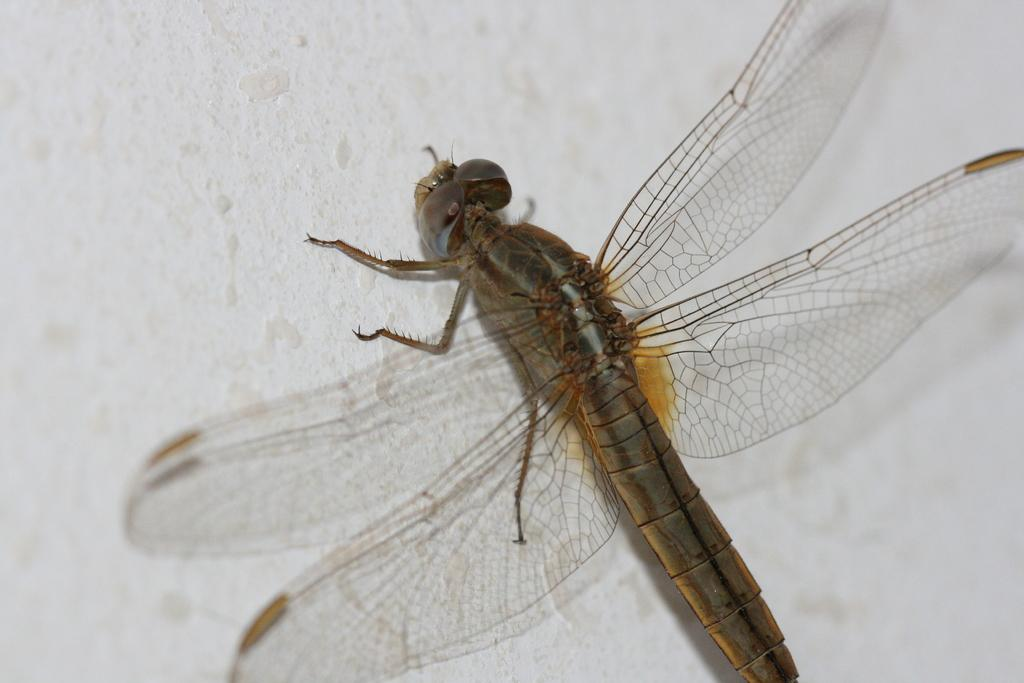What insect is present in the image? There is a dragonfly in the image. What is the color of the surface where the dragonfly is resting? The dragonfly is on a white surface. What type of sign can be seen in the cave where the bears are hibernating in the image? There is no cave, bears, or sign present in the image; it only features a dragonfly on a white surface. 